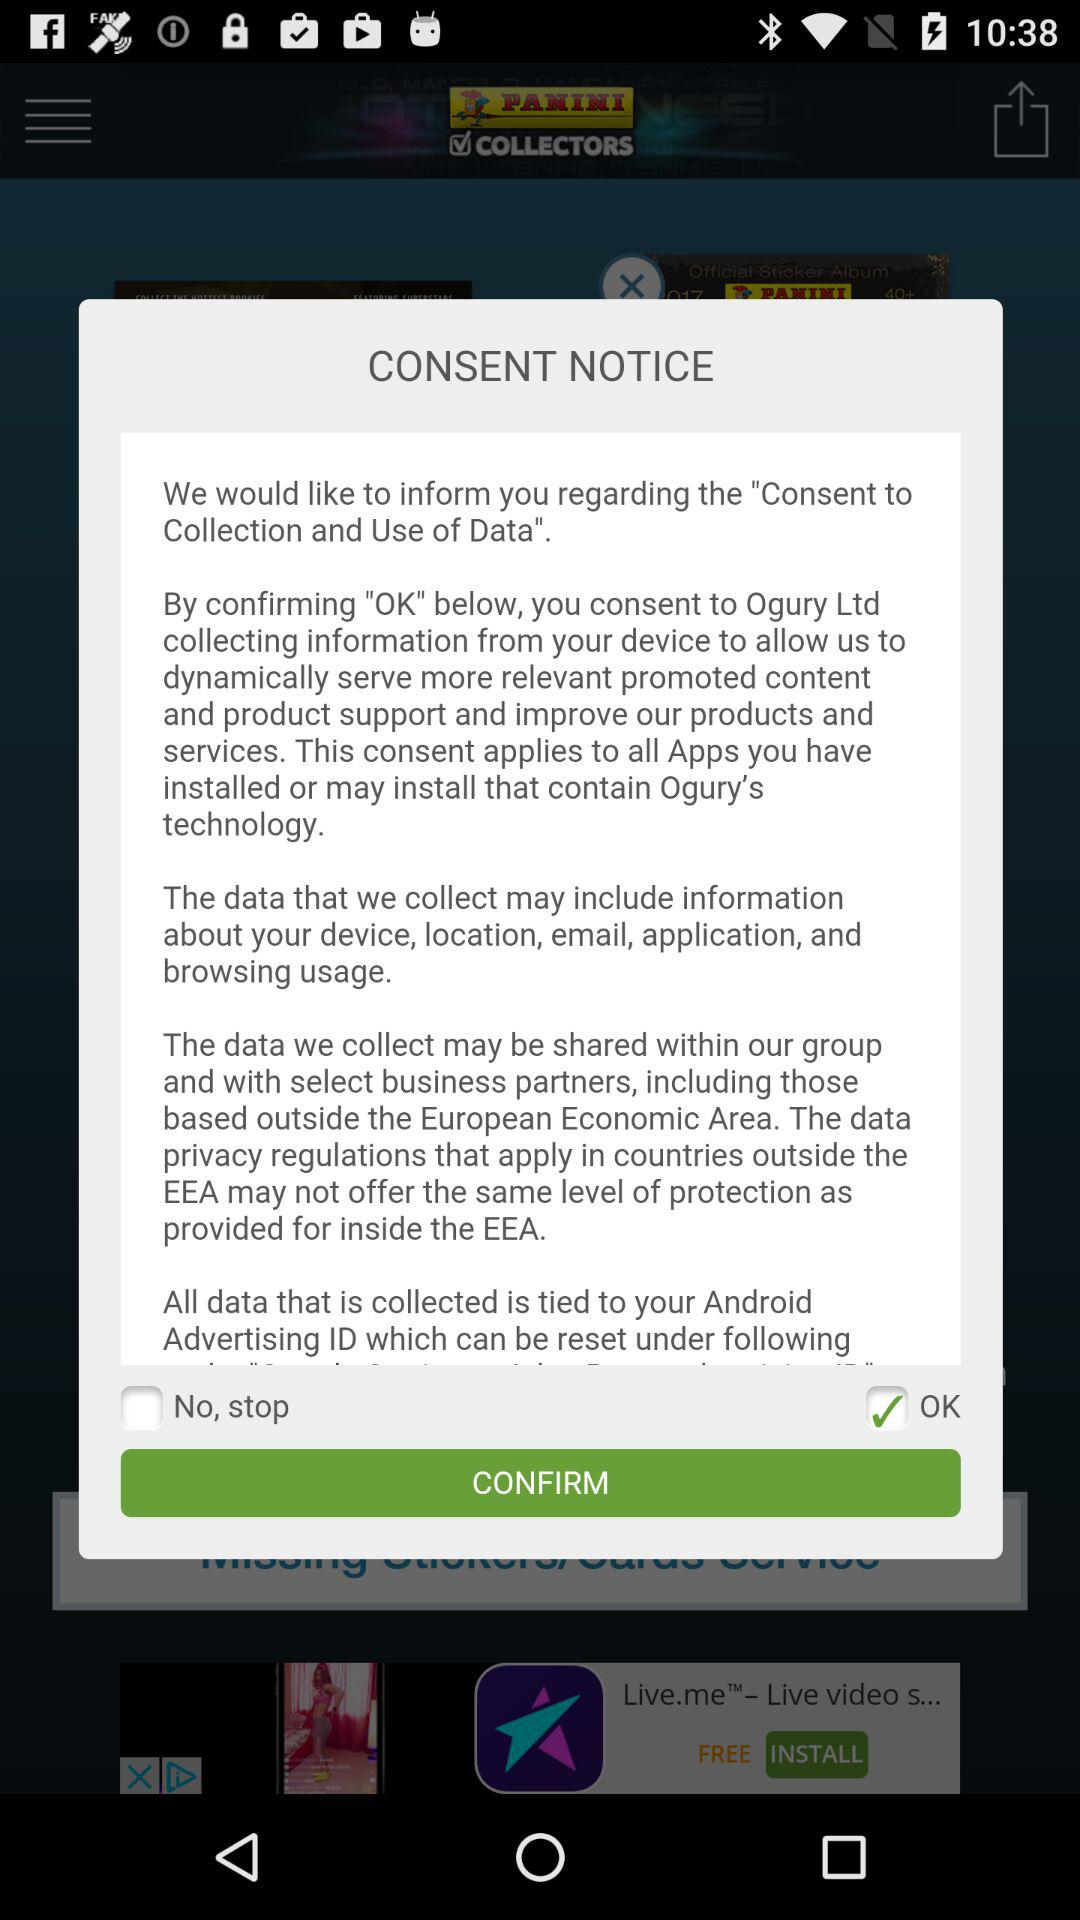What is the status of "OK"? The status of "OK" is "on". 